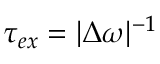Convert formula to latex. <formula><loc_0><loc_0><loc_500><loc_500>\tau _ { e x } = | \Delta \omega | ^ { - 1 }</formula> 